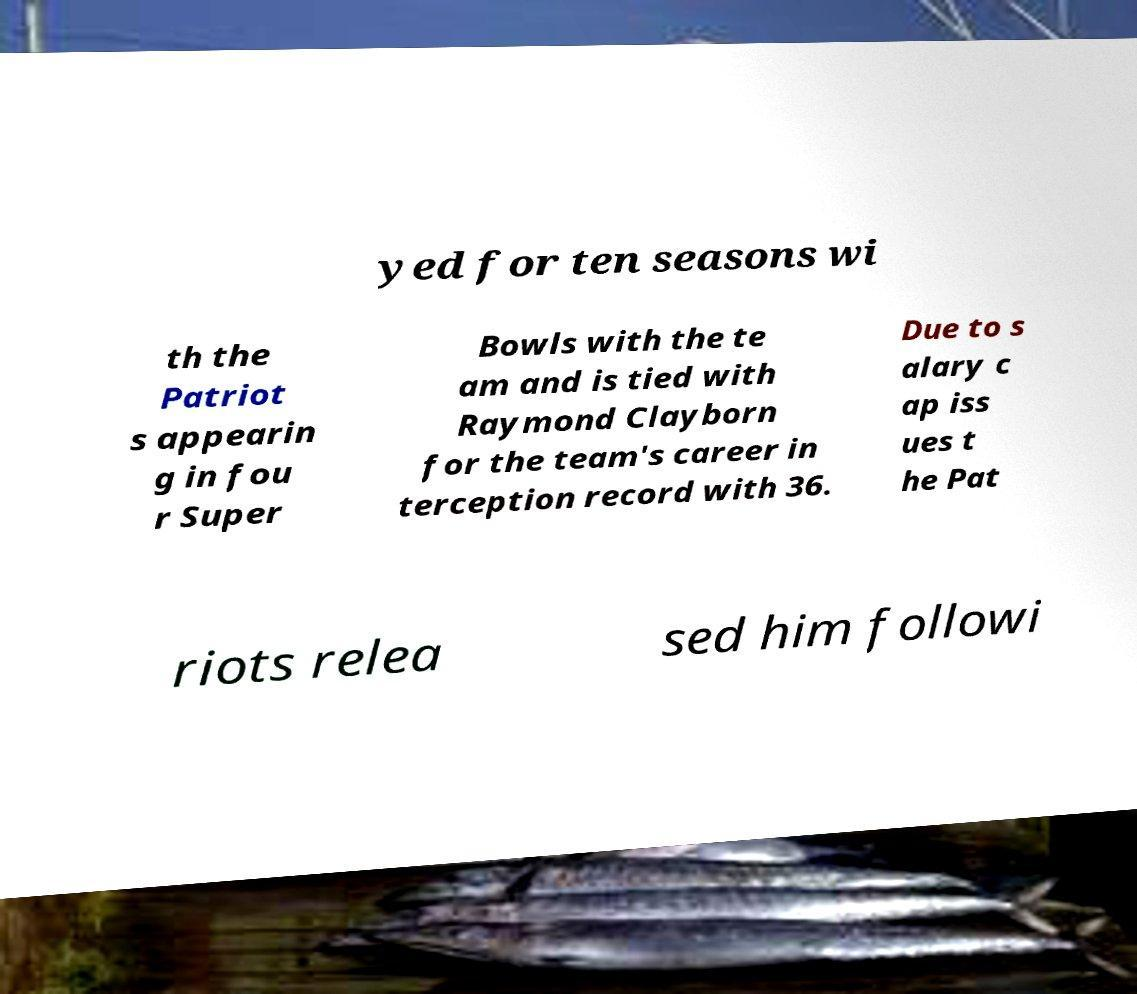Could you extract and type out the text from this image? yed for ten seasons wi th the Patriot s appearin g in fou r Super Bowls with the te am and is tied with Raymond Clayborn for the team's career in terception record with 36. Due to s alary c ap iss ues t he Pat riots relea sed him followi 